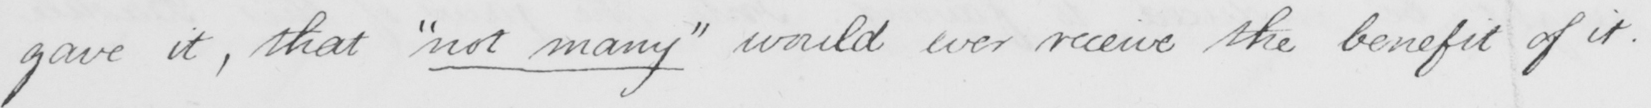What text is written in this handwritten line? gave it , that  " not many "  would ever receive the benefit of it .  _ 